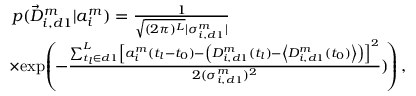<formula> <loc_0><loc_0><loc_500><loc_500>\begin{array} { r l } & { p ( \vec { D } _ { i , d 1 } ^ { m } | a _ { i } ^ { m } ) = \frac { 1 } { \sqrt { ( 2 \pi ) ^ { L } } | \sigma _ { i , d 1 } ^ { m } | } } \\ & { \, \times \, \exp \, \left ( \, - \frac { \sum _ { t _ { l } \in d 1 } ^ { L } \left [ a _ { i } ^ { m } ( t _ { l } - t _ { 0 } ) - \left ( D _ { i , d 1 } ^ { m } ( t _ { l } ) - \left < D _ { i , d 1 } ^ { m } ( t _ { 0 } ) \right > \right ) \right ] ^ { 2 } } { 2 ( \sigma _ { i , d 1 } ^ { m } ) ^ { 2 } } ) \, \right ) , } \end{array}</formula> 